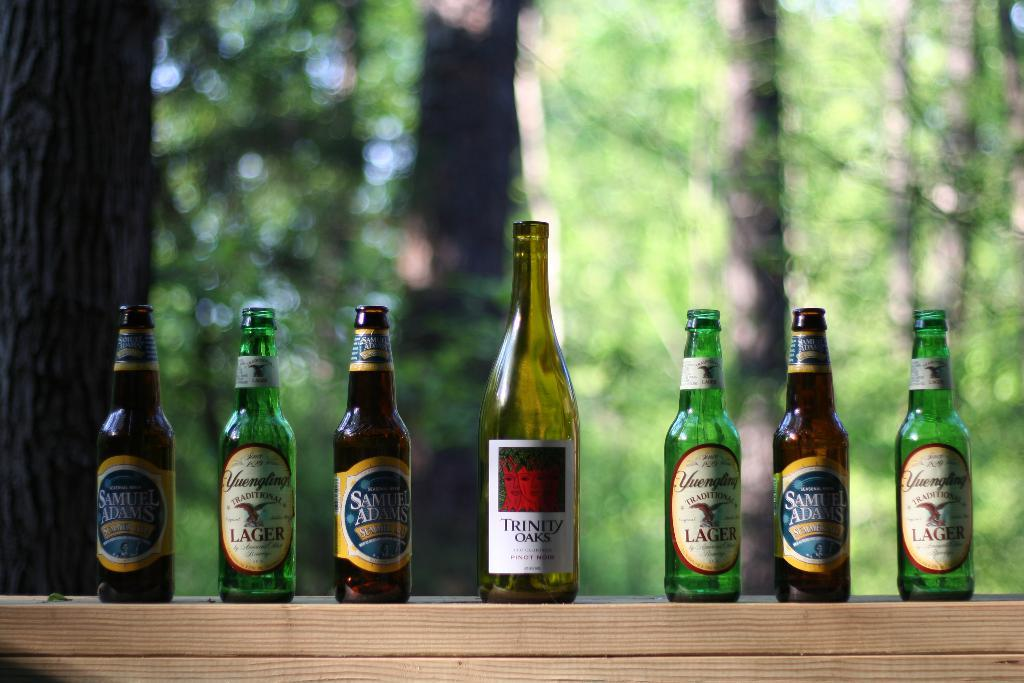<image>
Relay a brief, clear account of the picture shown. Different brands of beer bottles line each side of a Trinity Oaks wine bottle in the center, arranged on an outdoor shelf. 